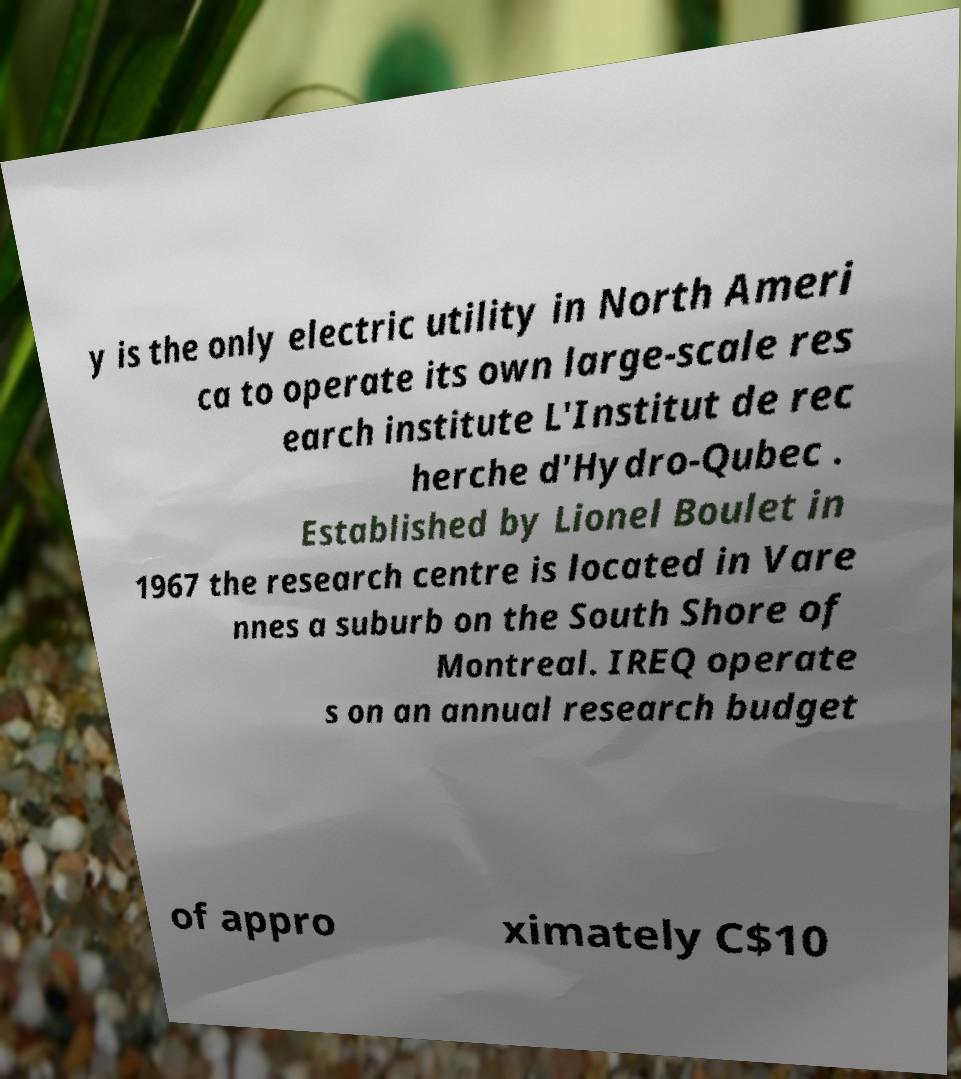I need the written content from this picture converted into text. Can you do that? y is the only electric utility in North Ameri ca to operate its own large-scale res earch institute L'Institut de rec herche d'Hydro-Qubec . Established by Lionel Boulet in 1967 the research centre is located in Vare nnes a suburb on the South Shore of Montreal. IREQ operate s on an annual research budget of appro ximately C$10 